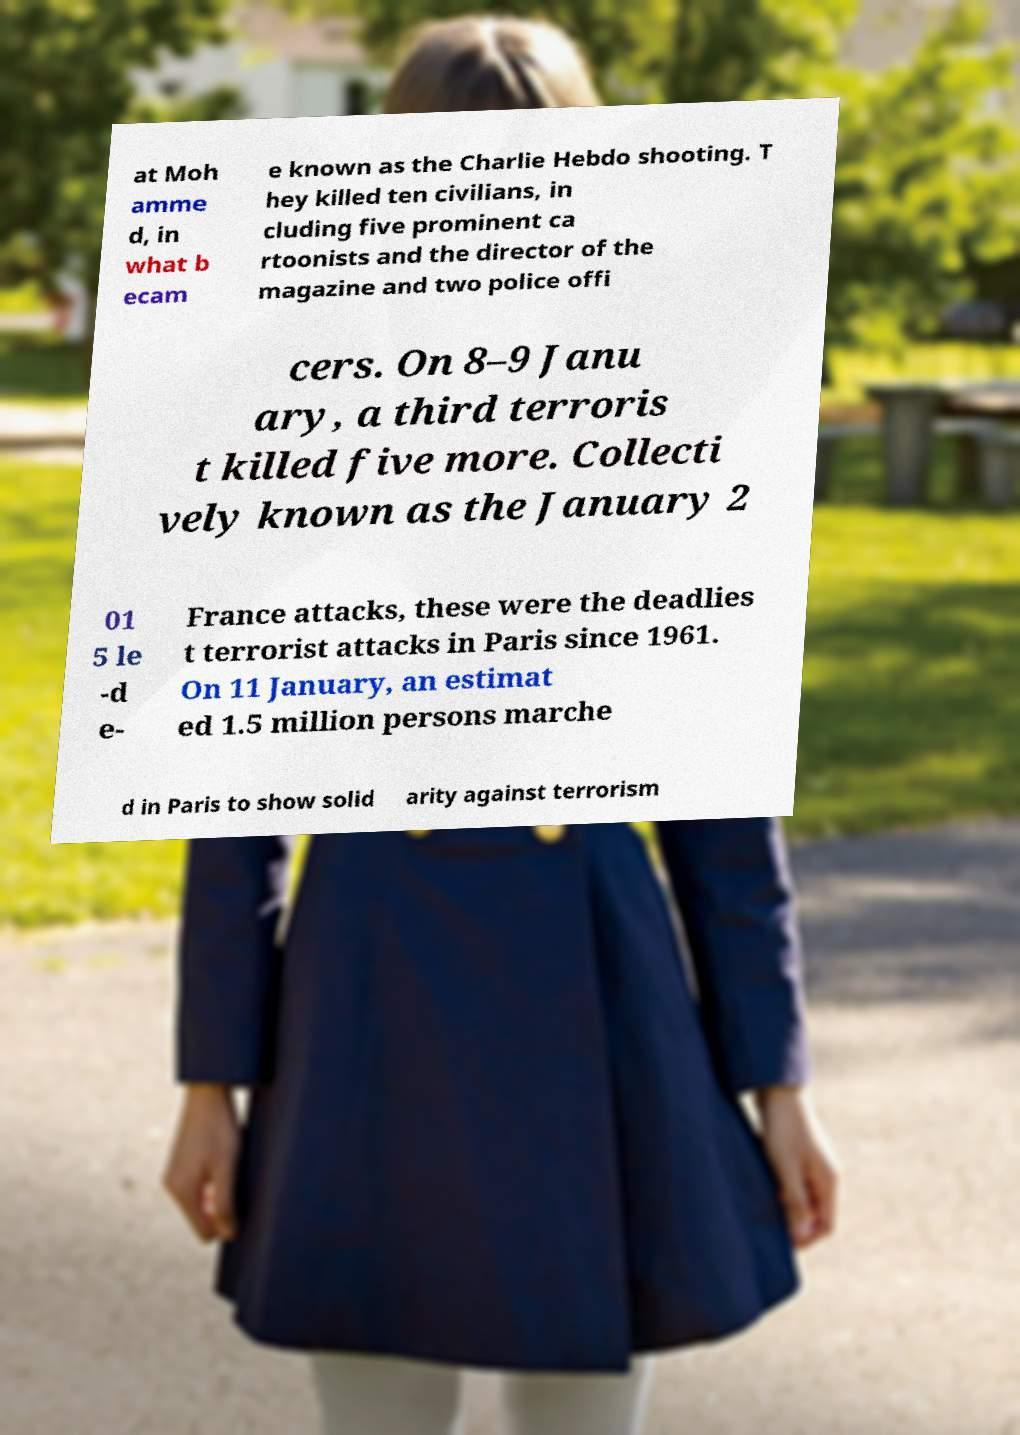Please read and relay the text visible in this image. What does it say? at Moh amme d, in what b ecam e known as the Charlie Hebdo shooting. T hey killed ten civilians, in cluding five prominent ca rtoonists and the director of the magazine and two police offi cers. On 8–9 Janu ary, a third terroris t killed five more. Collecti vely known as the January 2 01 5 le -d e- France attacks, these were the deadlies t terrorist attacks in Paris since 1961. On 11 January, an estimat ed 1.5 million persons marche d in Paris to show solid arity against terrorism 